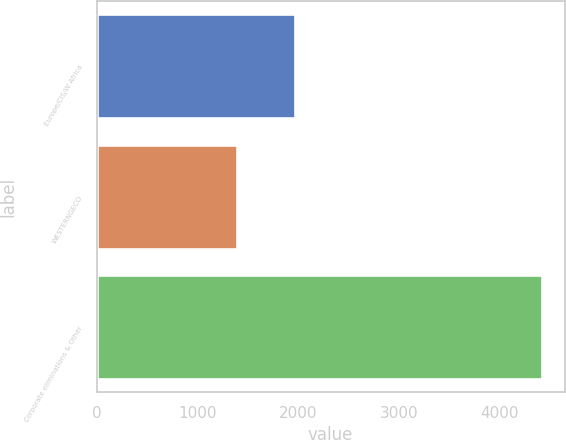Convert chart. <chart><loc_0><loc_0><loc_500><loc_500><bar_chart><fcel>Europe/CIS/W Africa<fcel>WESTERNGECO<fcel>Corporate eliminations & Other<nl><fcel>1974<fcel>1396<fcel>4428<nl></chart> 